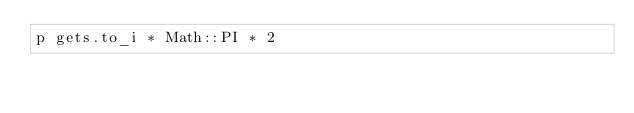Convert code to text. <code><loc_0><loc_0><loc_500><loc_500><_Ruby_>p gets.to_i * Math::PI * 2
</code> 